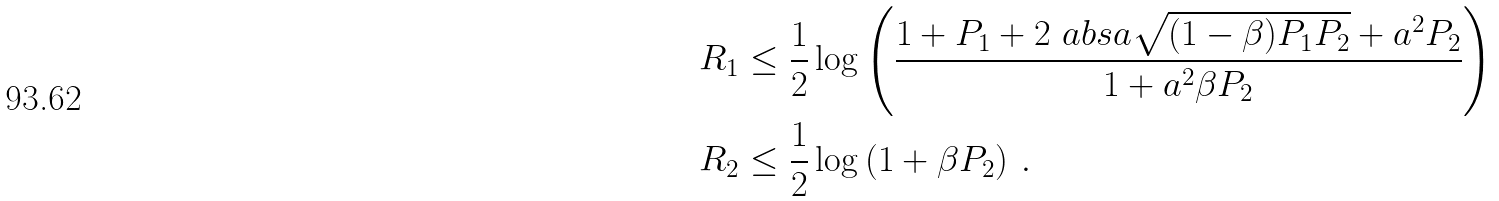Convert formula to latex. <formula><loc_0><loc_0><loc_500><loc_500>R _ { 1 } & \leq \frac { 1 } { 2 } \log \left ( \frac { 1 + P _ { 1 } + 2 \ a b s { a } \sqrt { ( 1 - \beta ) P _ { 1 } P _ { 2 } } + a ^ { 2 } P _ { 2 } } { 1 + a ^ { 2 } \beta P _ { 2 } } \right ) \\ R _ { 2 } & \leq \frac { 1 } { 2 } \log \left ( 1 + \beta P _ { 2 } \right ) \, .</formula> 